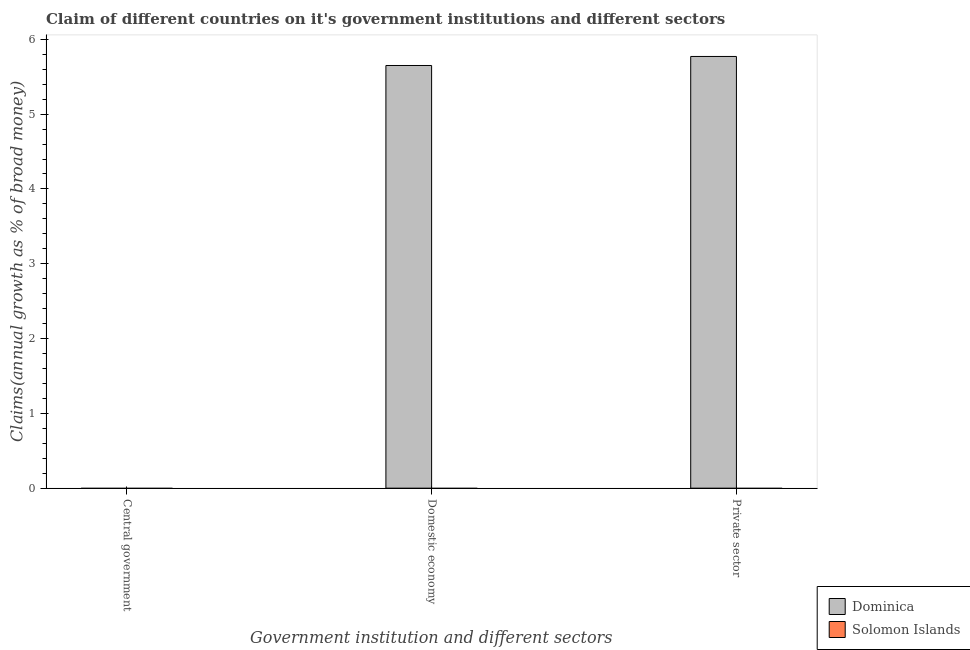How many different coloured bars are there?
Ensure brevity in your answer.  1. Are the number of bars per tick equal to the number of legend labels?
Provide a short and direct response. No. How many bars are there on the 3rd tick from the left?
Offer a terse response. 1. How many bars are there on the 2nd tick from the right?
Provide a succinct answer. 1. What is the label of the 1st group of bars from the left?
Your answer should be very brief. Central government. What is the percentage of claim on the private sector in Solomon Islands?
Offer a terse response. 0. Across all countries, what is the maximum percentage of claim on the domestic economy?
Ensure brevity in your answer.  5.65. In which country was the percentage of claim on the domestic economy maximum?
Provide a short and direct response. Dominica. What is the total percentage of claim on the domestic economy in the graph?
Keep it short and to the point. 5.65. What is the difference between the percentage of claim on the private sector in Solomon Islands and the percentage of claim on the domestic economy in Dominica?
Make the answer very short. -5.65. In how many countries, is the percentage of claim on the central government greater than 4.8 %?
Provide a short and direct response. 0. What is the difference between the highest and the lowest percentage of claim on the domestic economy?
Your answer should be very brief. 5.65. Are the values on the major ticks of Y-axis written in scientific E-notation?
Your response must be concise. No. How many legend labels are there?
Keep it short and to the point. 2. What is the title of the graph?
Provide a succinct answer. Claim of different countries on it's government institutions and different sectors. What is the label or title of the X-axis?
Give a very brief answer. Government institution and different sectors. What is the label or title of the Y-axis?
Offer a very short reply. Claims(annual growth as % of broad money). What is the Claims(annual growth as % of broad money) of Dominica in Central government?
Keep it short and to the point. 0. What is the Claims(annual growth as % of broad money) of Dominica in Domestic economy?
Provide a succinct answer. 5.65. What is the Claims(annual growth as % of broad money) in Solomon Islands in Domestic economy?
Offer a terse response. 0. What is the Claims(annual growth as % of broad money) of Dominica in Private sector?
Offer a terse response. 5.77. Across all Government institution and different sectors, what is the maximum Claims(annual growth as % of broad money) in Dominica?
Provide a short and direct response. 5.77. Across all Government institution and different sectors, what is the minimum Claims(annual growth as % of broad money) in Dominica?
Offer a terse response. 0. What is the total Claims(annual growth as % of broad money) of Dominica in the graph?
Your answer should be compact. 11.42. What is the difference between the Claims(annual growth as % of broad money) of Dominica in Domestic economy and that in Private sector?
Offer a terse response. -0.12. What is the average Claims(annual growth as % of broad money) in Dominica per Government institution and different sectors?
Your answer should be very brief. 3.81. What is the ratio of the Claims(annual growth as % of broad money) of Dominica in Domestic economy to that in Private sector?
Offer a very short reply. 0.98. What is the difference between the highest and the lowest Claims(annual growth as % of broad money) in Dominica?
Your answer should be very brief. 5.77. 